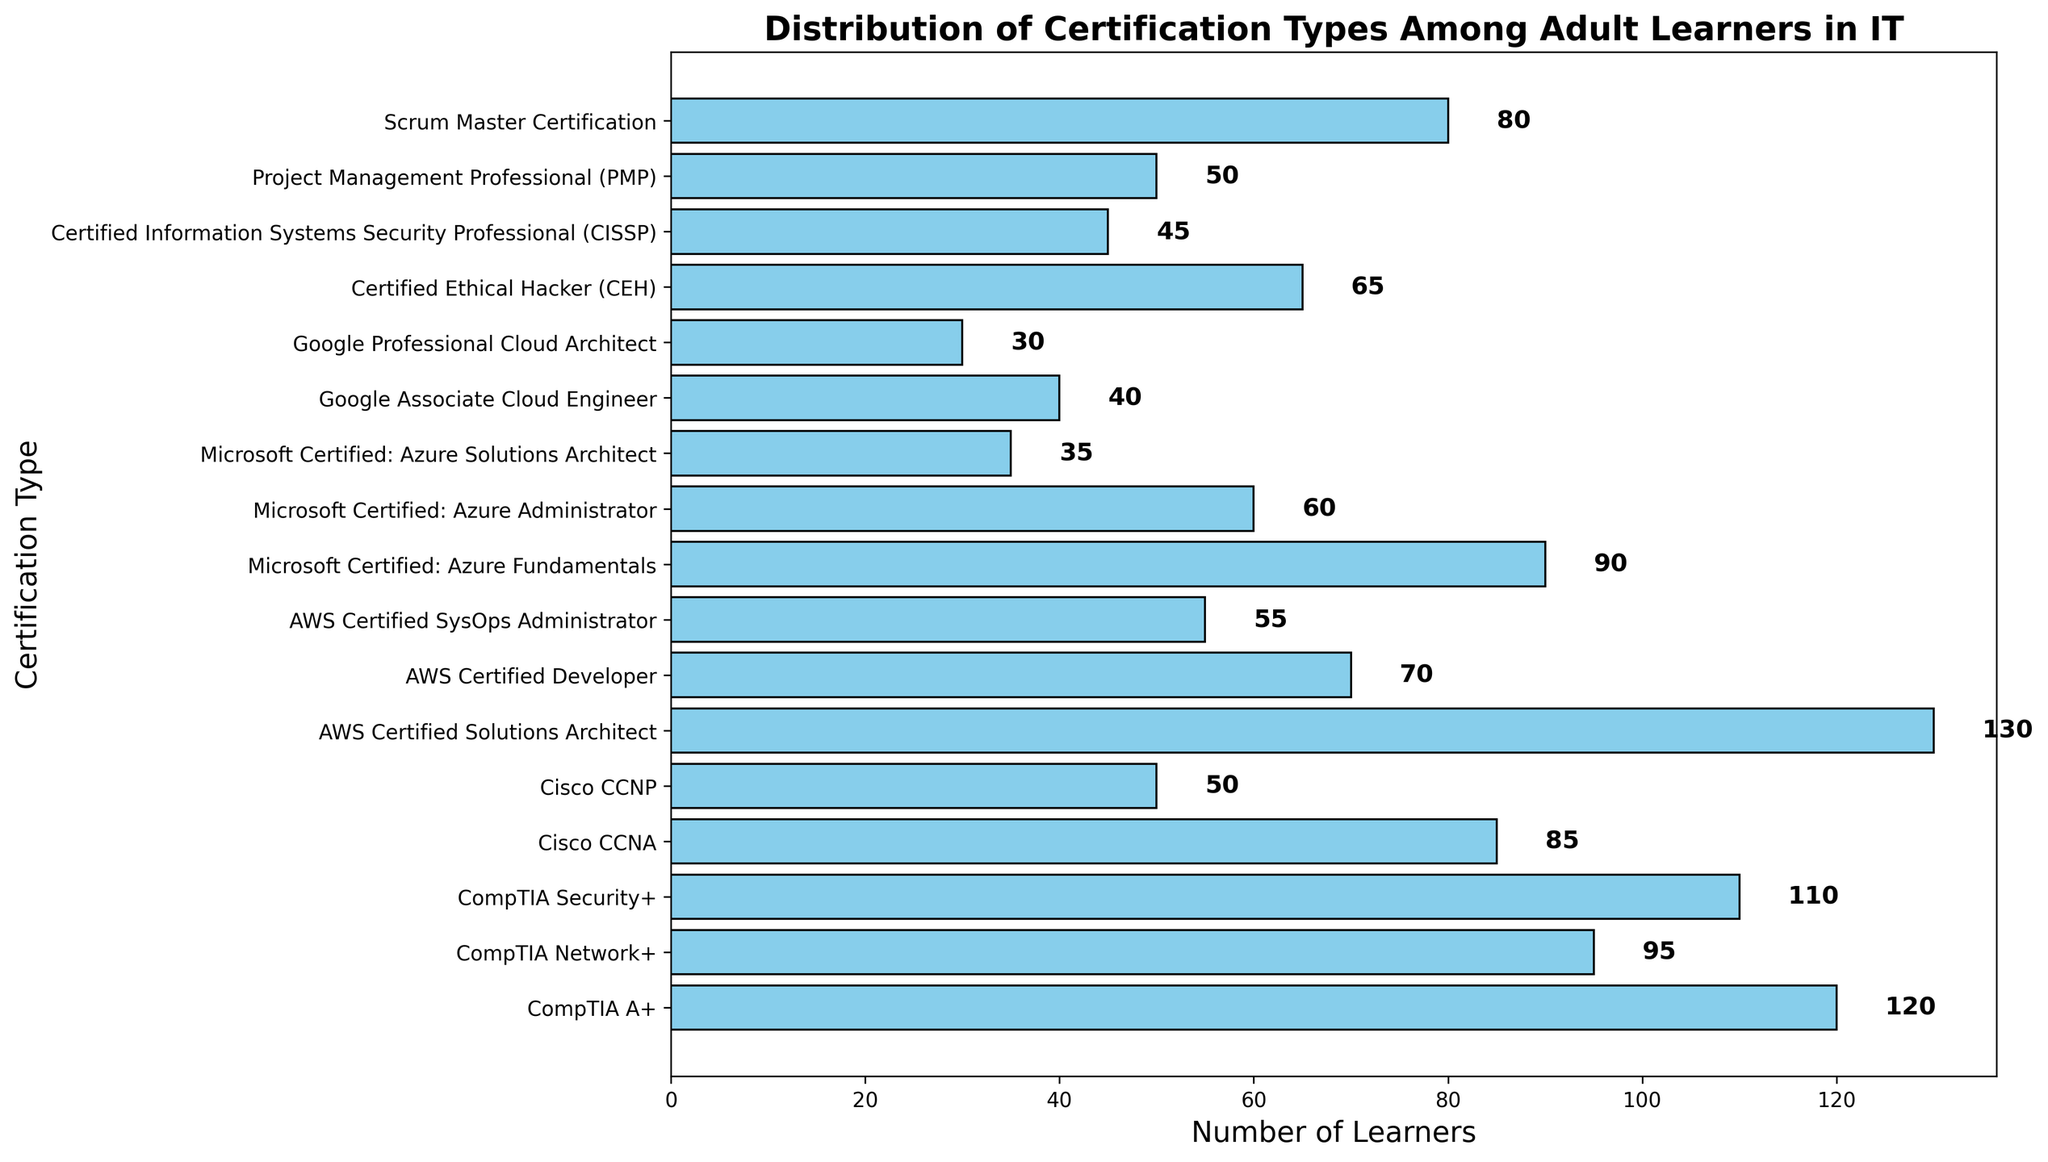Which certification type has the highest number of learners? The figure has bars of different lengths, representing the number of learners for each certification type. The bar corresponding to "AWS Certified Solutions Architect" is the longest.
Answer: AWS Certified Solutions Architect What is the total number of learners for CompTIA certifications? Summing up the number of learners for CompTIA A+ (120), CompTIA Network+ (95), and CompTIA Security+ (110): 120 + 95 + 110 = 325.
Answer: 325 How many learners have AWS certifications in total? Adding the number of learners for AWS Certified Solutions Architect (130), AWS Certified Developer (70), and AWS Certified SysOps Administrator (55): 130 + 70 + 55 = 255.
Answer: 255 Which has more learners: Cisco CCNA or Scrum Master Certification? The bar for "Scrum Master Certification" is longer than the bar for "Cisco CCNA". Scrum Master Certification has 80 learners, Cisco CCNA has 85 learners.
Answer: Cisco CCNA How many fewer learners are there for Google Professional Cloud Architect compared to Google Associate Cloud Engineer? Google Associate Cloud Engineer has 40 learners and Google Professional Cloud Architect has 30 learners. The difference is 40 - 30 = 10.
Answer: 10 Are there more learners with Microsoft Certified: Azure Administrator or Certified Ethical Hacker (CEH)? The bar for "Certified Ethical Hacker (CEH)" is longer than the bar for "Microsoft Certified: Azure Administrator". CEH has 65 learners, Azure Administrator has 60 learners.
Answer: Certified Ethical Hacker (CEH) What is the combined number of learners for Microsoft Certified: Azure Fundamentals and AWS Certified Developer? Microsoft Certified: Azure Fundamentals has 90 learners and AWS Certified Developer has 70 learners. The sum is 90 + 70 = 160.
Answer: 160 Which certification type has the smallest number of learners? The shortest bar corresponds to "Google Professional Cloud Architect", indicating the smallest number of learners.
Answer: Google Professional Cloud Architect How many more learners are there for AWS Certified Solutions Architect compared to Microsoft Certified: Azure Solutions Architect? AWS Certified Solutions Architect has 130 learners and Microsoft Certified: Azure Solutions Architect has 35 learners. The difference is 130 - 35 = 95.
Answer: 95 If learners with Microsoft and Google certifications are combined, what is the total number? Microsoft certifications include Azure Fundamentals (90), Azure Administrator (60), and Azure Solutions Architect (35) totaling 185. Google certifications include Associate Cloud Engineer (40) and Professional Cloud Architect (30) totaling 70. The combined total is 185 + 70 = 255.
Answer: 255 